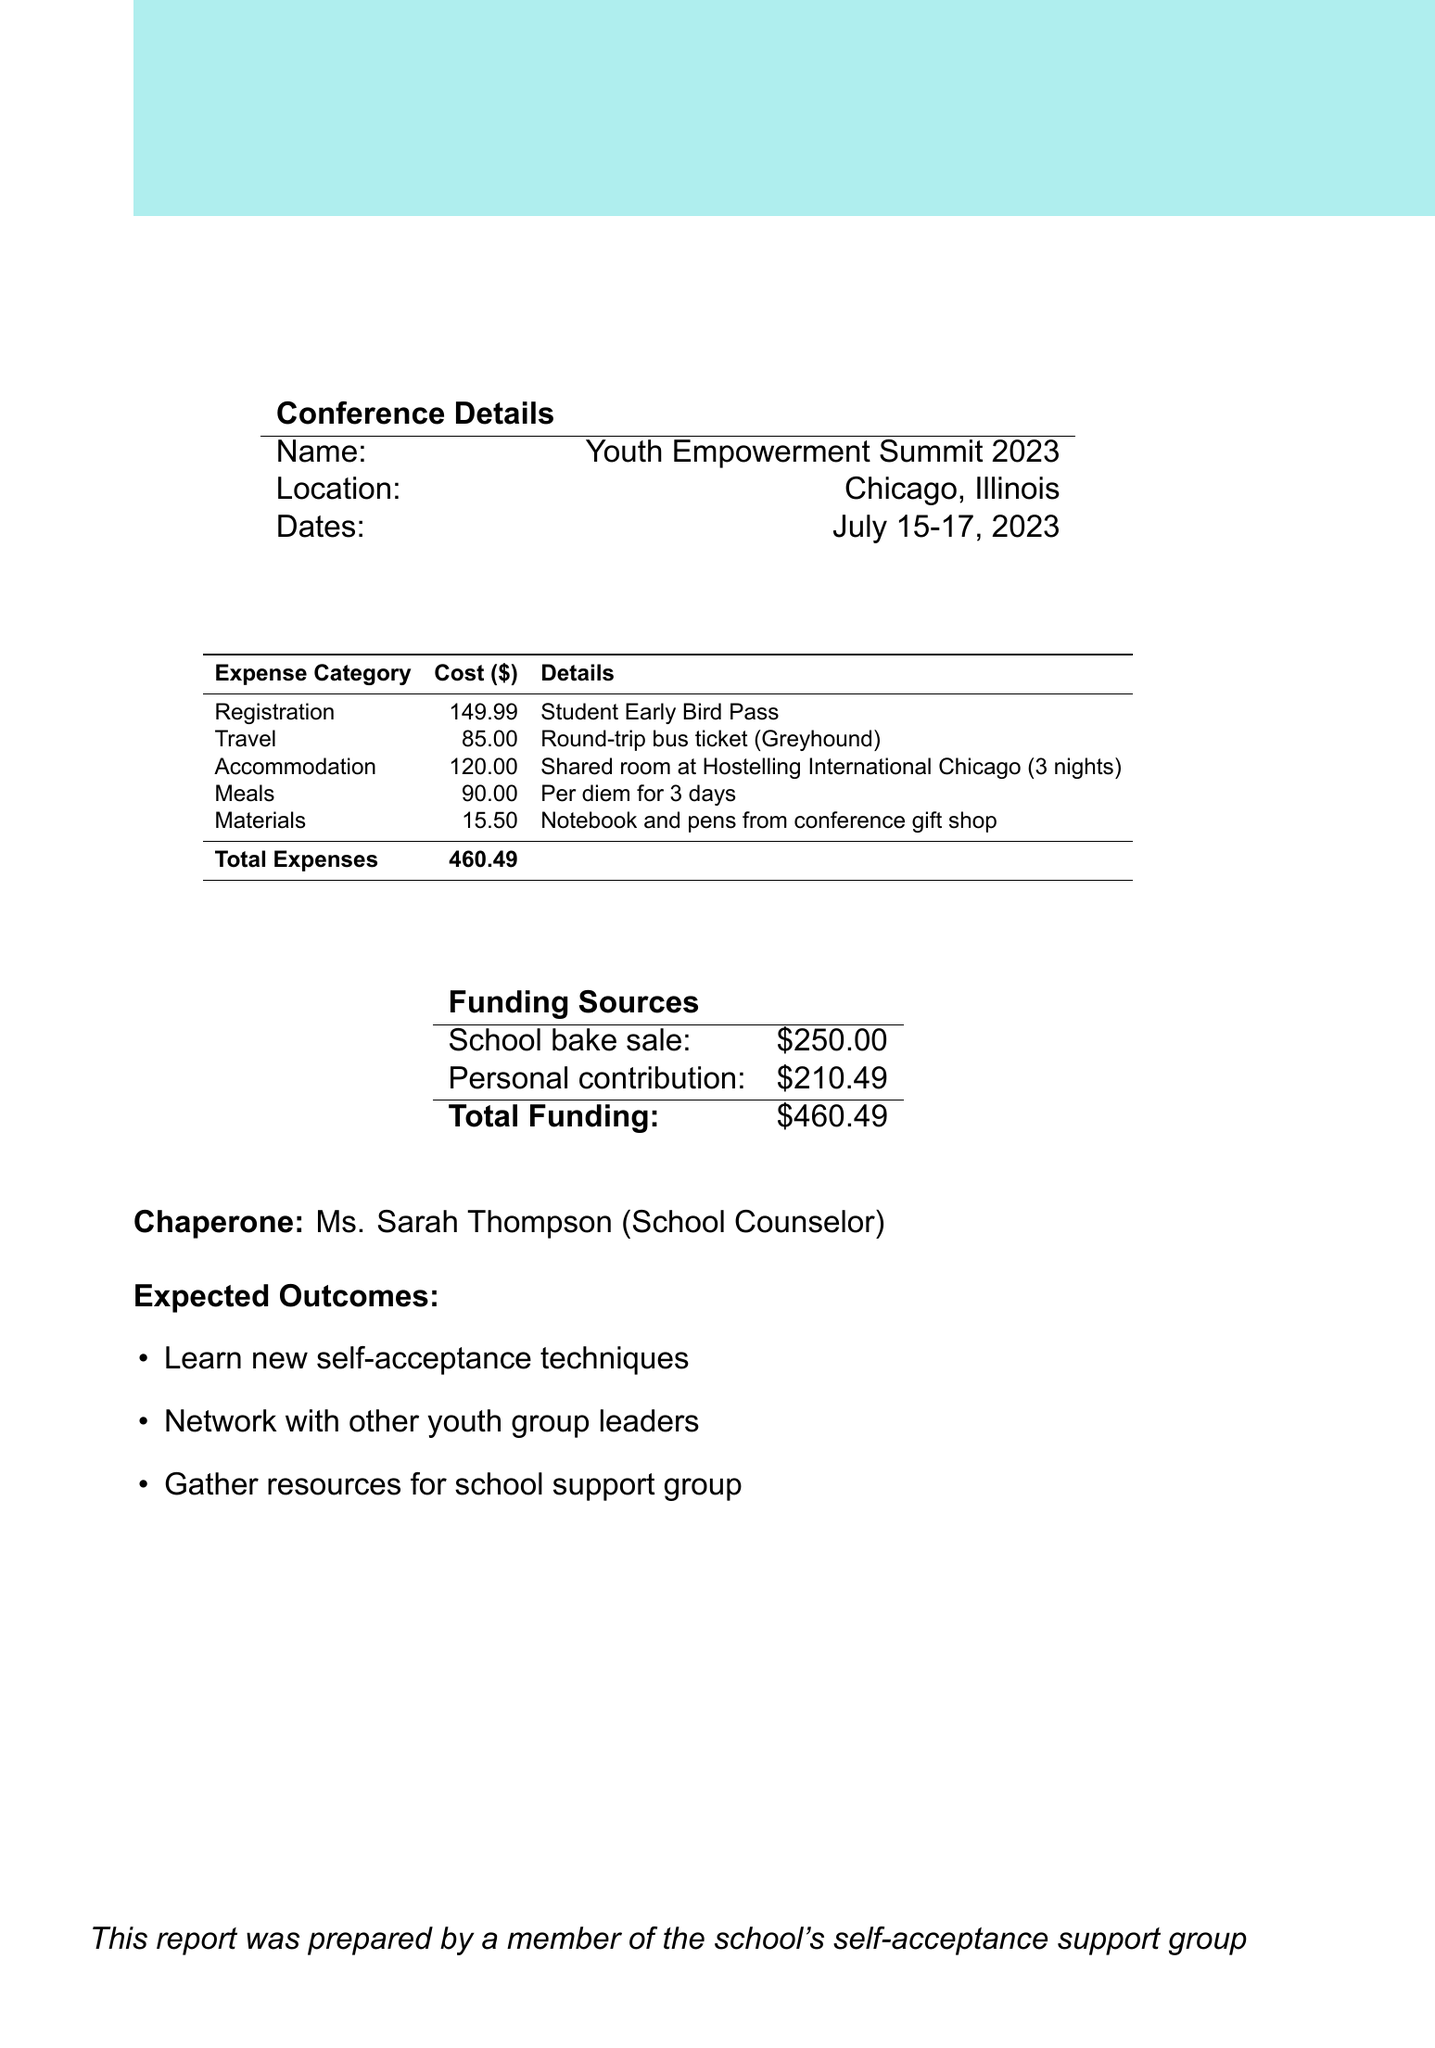What is the name of the conference? The name of the conference is explicitly mentioned in the conference details section as the "Youth Empowerment Summit 2023."
Answer: Youth Empowerment Summit 2023 Where is the conference located? The location of the conference is provided as "Chicago, Illinois" in the document's conference details section.
Answer: Chicago, Illinois What is the total cost of the expenses? The total cost of the expenses is explicitly calculated and mentioned as "$460.49" in the expenses section of the report.
Answer: $460.49 How much was raised from the school bake sale? The amount raised from the school bake sale is specified as "$250.00" in the funding sources table of the report.
Answer: $250.00 What is the personal contribution made to attend the conference? The personal contribution amount is clearly listed as "$210.49" in the funding sources section of the financial report.
Answer: $210.49 Who was the chaperone for the trip? The chaperone's name is mentioned in the report as "Ms. Sarah Thompson."
Answer: Ms. Sarah Thompson What were the expected outcomes of attending the conference? The expected outcomes are listed in bullet points, including new self-acceptance techniques, networking, and resources for the support group.
Answer: Learn new self-acceptance techniques How many nights was the accommodation booked for? The number of nights booked for accommodation is stated as "3 nights" in the accommodation expense detail.
Answer: 3 nights What kind of ticket was purchased for travel? The document specifies the purchased travel ticket as a "Round-trip bus ticket (Greyhound)."
Answer: Round-trip bus ticket (Greyhound) 